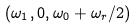<formula> <loc_0><loc_0><loc_500><loc_500>( \omega _ { 1 } , 0 , \omega _ { 0 } + \omega _ { r } / 2 )</formula> 